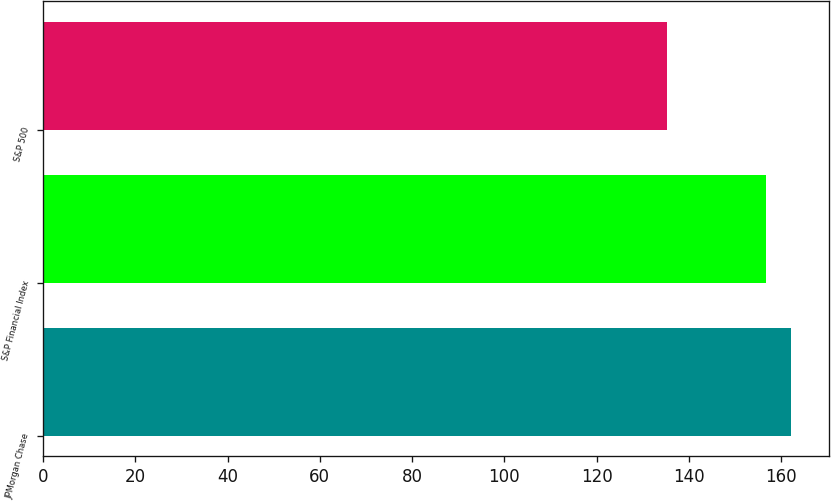Convert chart to OTSL. <chart><loc_0><loc_0><loc_500><loc_500><bar_chart><fcel>JPMorgan Chase<fcel>S&P Financial Index<fcel>S&P 500<nl><fcel>162.21<fcel>156.82<fcel>135.2<nl></chart> 